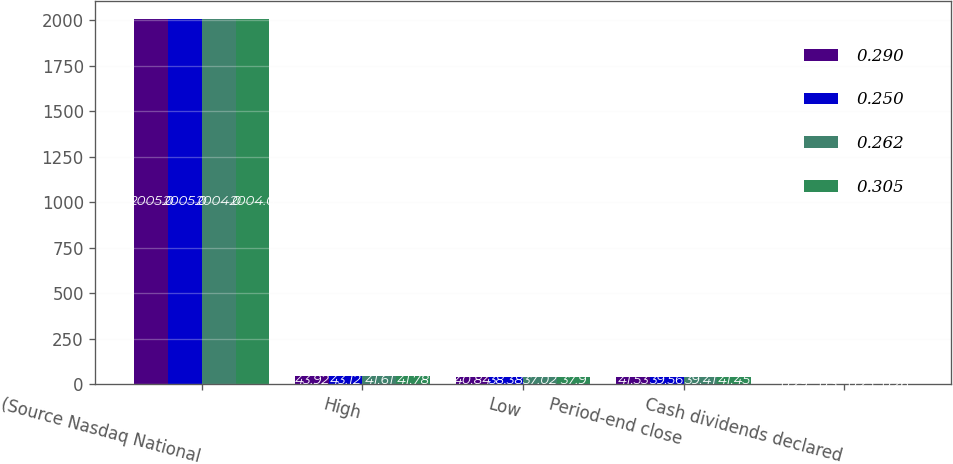<chart> <loc_0><loc_0><loc_500><loc_500><stacked_bar_chart><ecel><fcel>(Source Nasdaq National<fcel>High<fcel>Low<fcel>Period-end close<fcel>Cash dividends declared<nl><fcel>0.29<fcel>2005<fcel>43.92<fcel>40.84<fcel>41.53<fcel>0.29<nl><fcel>0.25<fcel>2005<fcel>43.12<fcel>38.38<fcel>39.56<fcel>0.3<nl><fcel>0.262<fcel>2004<fcel>41.61<fcel>37.02<fcel>39.41<fcel>0.25<nl><fcel>0.305<fcel>2004<fcel>41.78<fcel>37.9<fcel>41.45<fcel>0.26<nl></chart> 